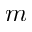<formula> <loc_0><loc_0><loc_500><loc_500>m</formula> 